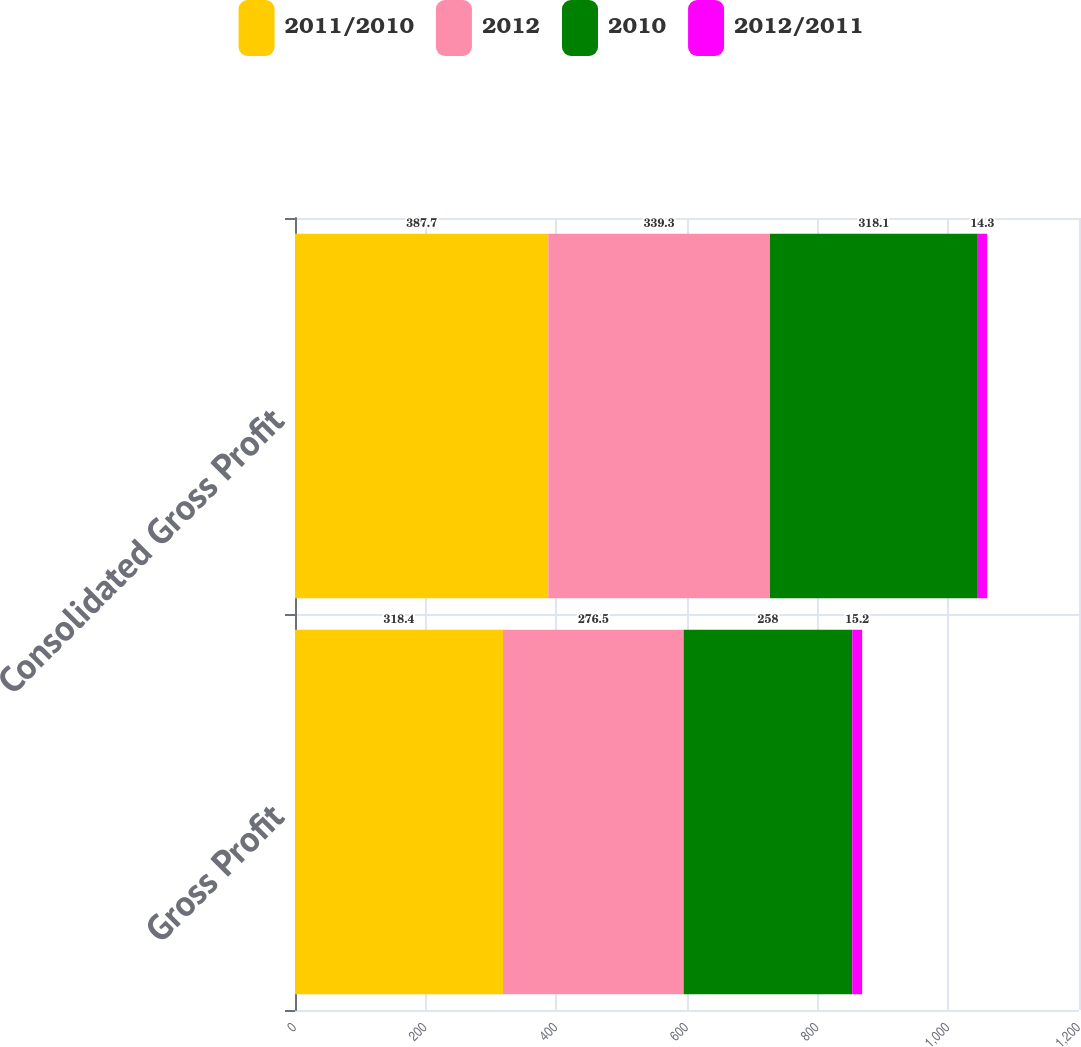<chart> <loc_0><loc_0><loc_500><loc_500><stacked_bar_chart><ecel><fcel>Gross Profit<fcel>Consolidated Gross Profit<nl><fcel>2011/2010<fcel>318.4<fcel>387.7<nl><fcel>2012<fcel>276.5<fcel>339.3<nl><fcel>2010<fcel>258<fcel>318.1<nl><fcel>2012/2011<fcel>15.2<fcel>14.3<nl></chart> 